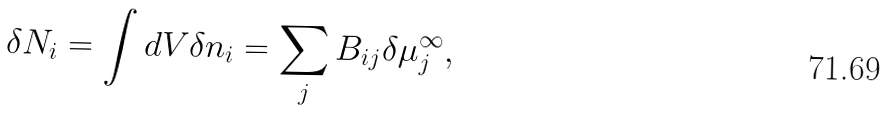<formula> <loc_0><loc_0><loc_500><loc_500>\delta N _ { i } = \int d V \delta n _ { i } = \sum _ { j } B _ { i j } \delta \mu _ { j } ^ { \infty } ,</formula> 